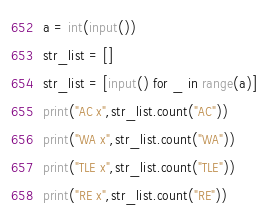<code> <loc_0><loc_0><loc_500><loc_500><_Python_>a = int(input())
str_list = []
str_list = [input() for _ in range(a)]
print("AC x",str_list.count("AC"))
print("WA x",str_list.count("WA"))
print("TLE x",str_list.count("TLE"))
print("RE x",str_list.count("RE"))</code> 